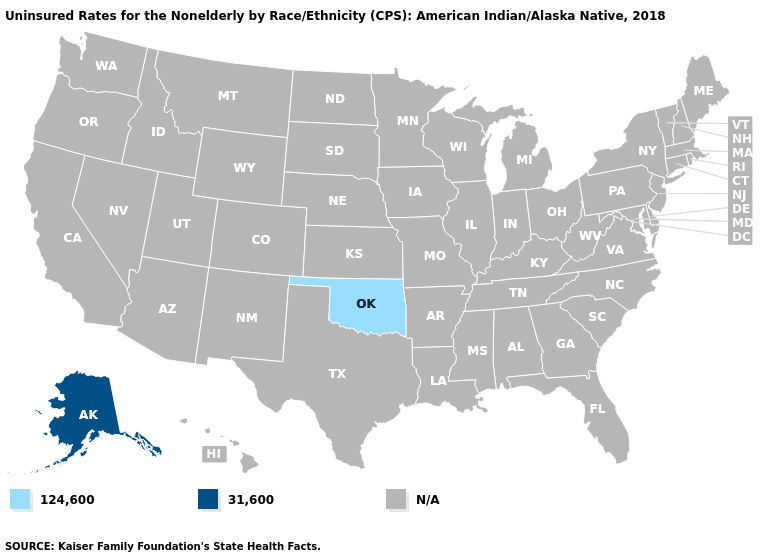Does Alaska have the lowest value in the USA?
Be succinct. No. What is the value of Maryland?
Quick response, please. N/A. What is the lowest value in the West?
Be succinct. 31,600. Which states have the highest value in the USA?
Answer briefly. Alaska. What is the highest value in the USA?
Give a very brief answer. 31,600. Is the legend a continuous bar?
Answer briefly. No. What is the value of Minnesota?
Quick response, please. N/A. Does Alaska have the highest value in the USA?
Write a very short answer. Yes. 